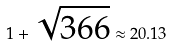Convert formula to latex. <formula><loc_0><loc_0><loc_500><loc_500>1 + \sqrt { 3 6 6 } \approx 2 0 . 1 3</formula> 